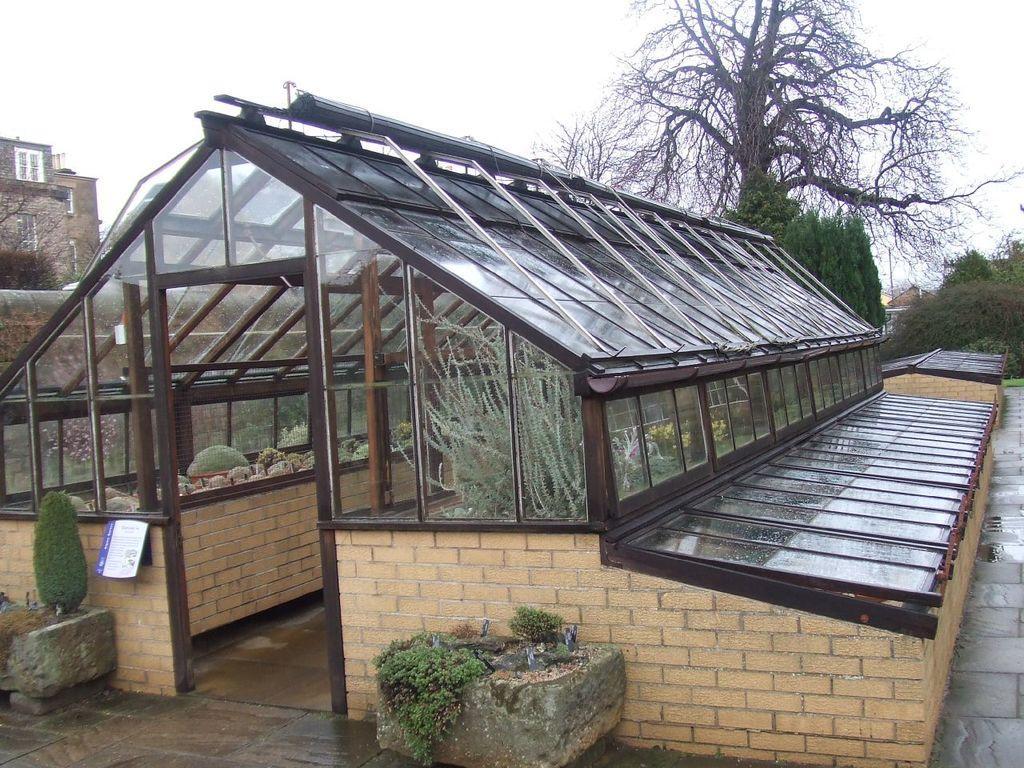Could you give a brief overview of what you see in this image? In this image I can see a shed, house plants, trees, building and the sky. This image is taken may be during a day. 